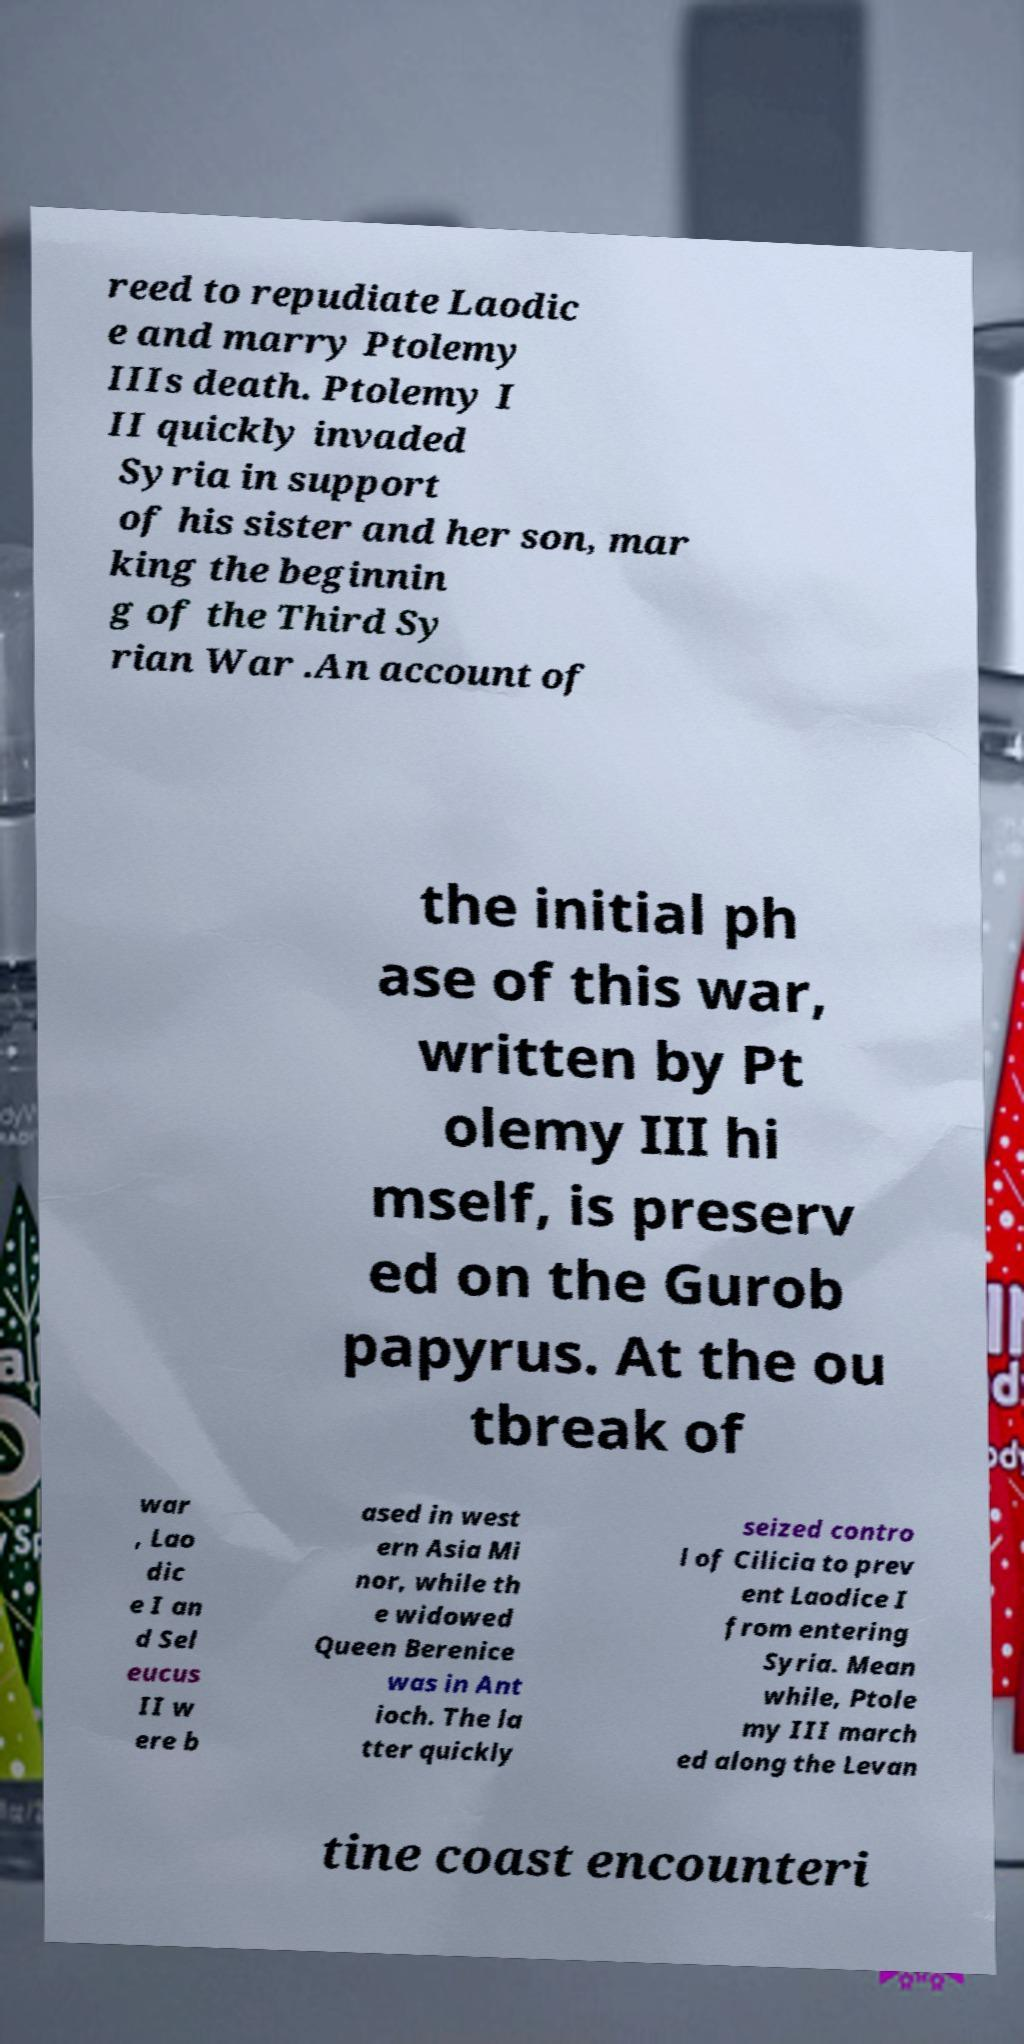Can you accurately transcribe the text from the provided image for me? reed to repudiate Laodic e and marry Ptolemy IIIs death. Ptolemy I II quickly invaded Syria in support of his sister and her son, mar king the beginnin g of the Third Sy rian War .An account of the initial ph ase of this war, written by Pt olemy III hi mself, is preserv ed on the Gurob papyrus. At the ou tbreak of war , Lao dic e I an d Sel eucus II w ere b ased in west ern Asia Mi nor, while th e widowed Queen Berenice was in Ant ioch. The la tter quickly seized contro l of Cilicia to prev ent Laodice I from entering Syria. Mean while, Ptole my III march ed along the Levan tine coast encounteri 